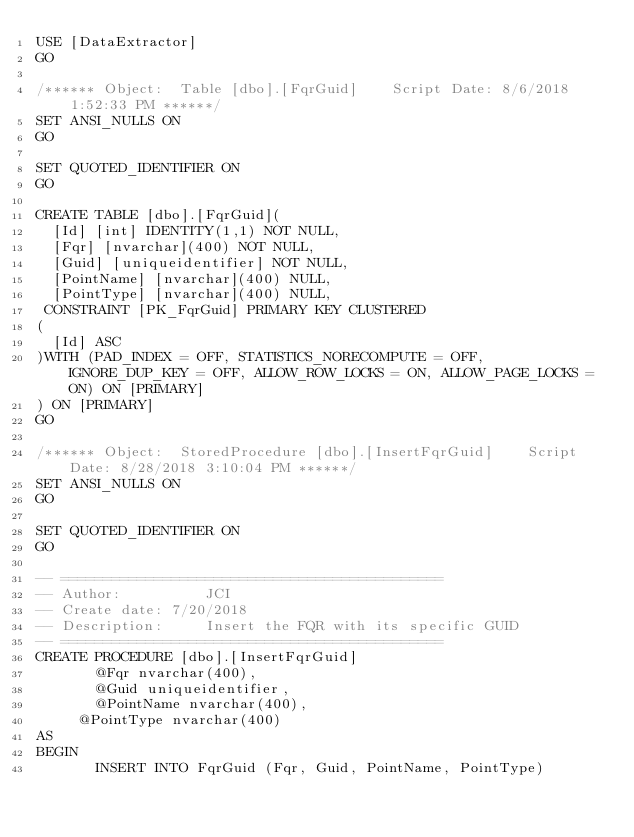Convert code to text. <code><loc_0><loc_0><loc_500><loc_500><_SQL_>USE [DataExtractor]
GO

/****** Object:  Table [dbo].[FqrGuid]    Script Date: 8/6/2018 1:52:33 PM ******/
SET ANSI_NULLS ON
GO

SET QUOTED_IDENTIFIER ON
GO

CREATE TABLE [dbo].[FqrGuid](
	[Id] [int] IDENTITY(1,1) NOT NULL,
	[Fqr] [nvarchar](400) NOT NULL,
	[Guid] [uniqueidentifier] NOT NULL,
	[PointName] [nvarchar](400) NULL,
	[PointType] [nvarchar](400) NULL,
 CONSTRAINT [PK_FqrGuid] PRIMARY KEY CLUSTERED 
(
	[Id] ASC
)WITH (PAD_INDEX = OFF, STATISTICS_NORECOMPUTE = OFF, IGNORE_DUP_KEY = OFF, ALLOW_ROW_LOCKS = ON, ALLOW_PAGE_LOCKS = ON) ON [PRIMARY]
) ON [PRIMARY]
GO

/****** Object:  StoredProcedure [dbo].[InsertFqrGuid]    Script Date: 8/28/2018 3:10:04 PM ******/
SET ANSI_NULLS ON
GO

SET QUOTED_IDENTIFIER ON
GO

-- =============================================
-- Author:          JCI
-- Create date: 7/20/2018
-- Description:     Insert the FQR with its specific GUID
-- =============================================
CREATE PROCEDURE [dbo].[InsertFqrGuid] 
       @Fqr nvarchar(400),
       @Guid uniqueidentifier,
       @PointName nvarchar(400),
	   @PointType nvarchar(400)
AS
BEGIN
       INSERT INTO FqrGuid (Fqr, Guid, PointName, PointType)</code> 